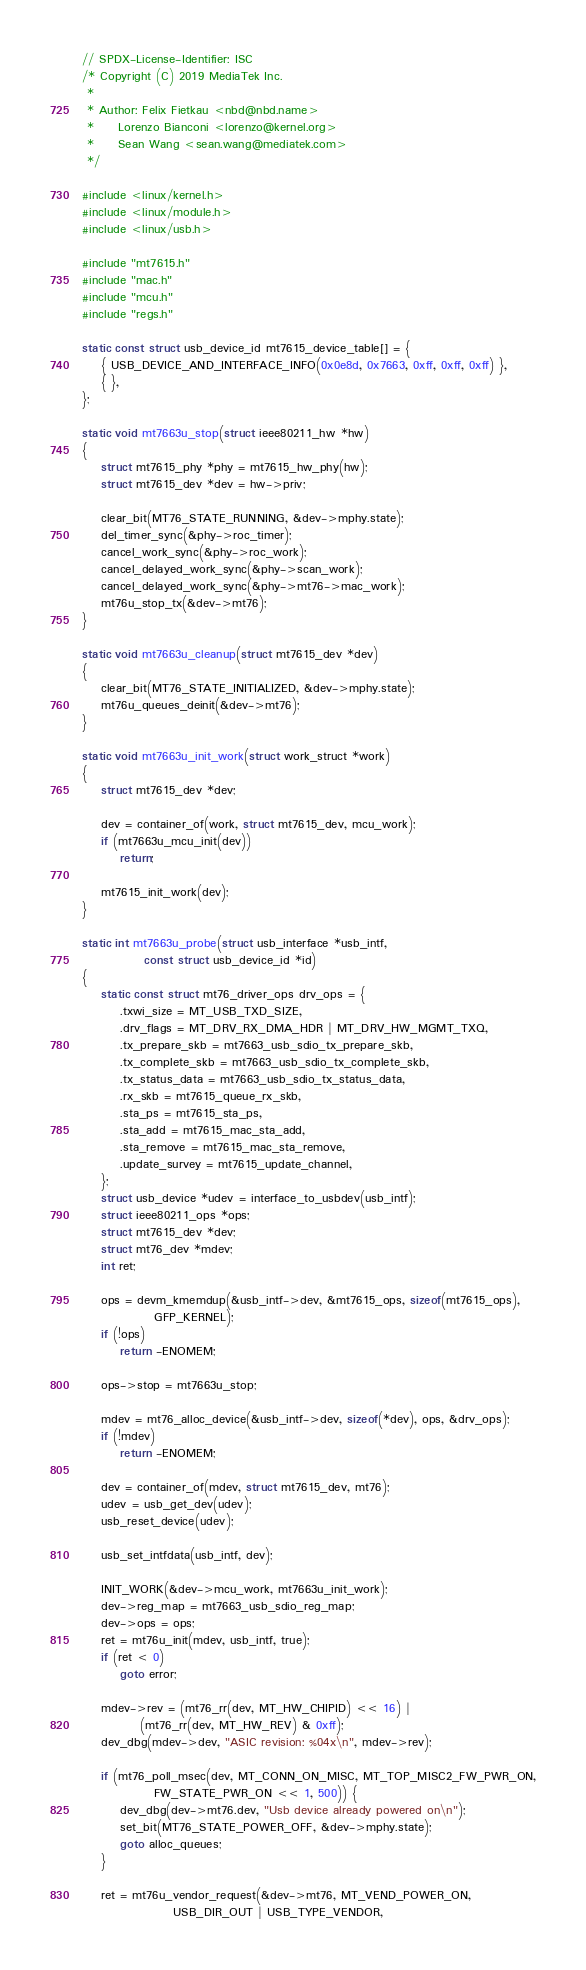<code> <loc_0><loc_0><loc_500><loc_500><_C_>// SPDX-License-Identifier: ISC
/* Copyright (C) 2019 MediaTek Inc.
 *
 * Author: Felix Fietkau <nbd@nbd.name>
 *	   Lorenzo Bianconi <lorenzo@kernel.org>
 *	   Sean Wang <sean.wang@mediatek.com>
 */

#include <linux/kernel.h>
#include <linux/module.h>
#include <linux/usb.h>

#include "mt7615.h"
#include "mac.h"
#include "mcu.h"
#include "regs.h"

static const struct usb_device_id mt7615_device_table[] = {
	{ USB_DEVICE_AND_INTERFACE_INFO(0x0e8d, 0x7663, 0xff, 0xff, 0xff) },
	{ },
};

static void mt7663u_stop(struct ieee80211_hw *hw)
{
	struct mt7615_phy *phy = mt7615_hw_phy(hw);
	struct mt7615_dev *dev = hw->priv;

	clear_bit(MT76_STATE_RUNNING, &dev->mphy.state);
	del_timer_sync(&phy->roc_timer);
	cancel_work_sync(&phy->roc_work);
	cancel_delayed_work_sync(&phy->scan_work);
	cancel_delayed_work_sync(&phy->mt76->mac_work);
	mt76u_stop_tx(&dev->mt76);
}

static void mt7663u_cleanup(struct mt7615_dev *dev)
{
	clear_bit(MT76_STATE_INITIALIZED, &dev->mphy.state);
	mt76u_queues_deinit(&dev->mt76);
}

static void mt7663u_init_work(struct work_struct *work)
{
	struct mt7615_dev *dev;

	dev = container_of(work, struct mt7615_dev, mcu_work);
	if (mt7663u_mcu_init(dev))
		return;

	mt7615_init_work(dev);
}

static int mt7663u_probe(struct usb_interface *usb_intf,
			 const struct usb_device_id *id)
{
	static const struct mt76_driver_ops drv_ops = {
		.txwi_size = MT_USB_TXD_SIZE,
		.drv_flags = MT_DRV_RX_DMA_HDR | MT_DRV_HW_MGMT_TXQ,
		.tx_prepare_skb = mt7663_usb_sdio_tx_prepare_skb,
		.tx_complete_skb = mt7663_usb_sdio_tx_complete_skb,
		.tx_status_data = mt7663_usb_sdio_tx_status_data,
		.rx_skb = mt7615_queue_rx_skb,
		.sta_ps = mt7615_sta_ps,
		.sta_add = mt7615_mac_sta_add,
		.sta_remove = mt7615_mac_sta_remove,
		.update_survey = mt7615_update_channel,
	};
	struct usb_device *udev = interface_to_usbdev(usb_intf);
	struct ieee80211_ops *ops;
	struct mt7615_dev *dev;
	struct mt76_dev *mdev;
	int ret;

	ops = devm_kmemdup(&usb_intf->dev, &mt7615_ops, sizeof(mt7615_ops),
			   GFP_KERNEL);
	if (!ops)
		return -ENOMEM;

	ops->stop = mt7663u_stop;

	mdev = mt76_alloc_device(&usb_intf->dev, sizeof(*dev), ops, &drv_ops);
	if (!mdev)
		return -ENOMEM;

	dev = container_of(mdev, struct mt7615_dev, mt76);
	udev = usb_get_dev(udev);
	usb_reset_device(udev);

	usb_set_intfdata(usb_intf, dev);

	INIT_WORK(&dev->mcu_work, mt7663u_init_work);
	dev->reg_map = mt7663_usb_sdio_reg_map;
	dev->ops = ops;
	ret = mt76u_init(mdev, usb_intf, true);
	if (ret < 0)
		goto error;

	mdev->rev = (mt76_rr(dev, MT_HW_CHIPID) << 16) |
		    (mt76_rr(dev, MT_HW_REV) & 0xff);
	dev_dbg(mdev->dev, "ASIC revision: %04x\n", mdev->rev);

	if (mt76_poll_msec(dev, MT_CONN_ON_MISC, MT_TOP_MISC2_FW_PWR_ON,
			   FW_STATE_PWR_ON << 1, 500)) {
		dev_dbg(dev->mt76.dev, "Usb device already powered on\n");
		set_bit(MT76_STATE_POWER_OFF, &dev->mphy.state);
		goto alloc_queues;
	}

	ret = mt76u_vendor_request(&dev->mt76, MT_VEND_POWER_ON,
				   USB_DIR_OUT | USB_TYPE_VENDOR,</code> 